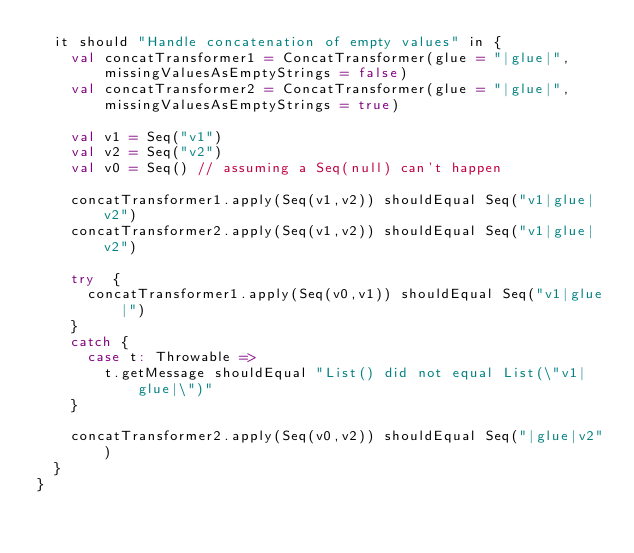Convert code to text. <code><loc_0><loc_0><loc_500><loc_500><_Scala_>  it should "Handle concatenation of empty values" in {
    val concatTransformer1 = ConcatTransformer(glue = "|glue|", missingValuesAsEmptyStrings = false)
    val concatTransformer2 = ConcatTransformer(glue = "|glue|", missingValuesAsEmptyStrings = true)

    val v1 = Seq("v1")
    val v2 = Seq("v2")
    val v0 = Seq() // assuming a Seq(null) can't happen

    concatTransformer1.apply(Seq(v1,v2)) shouldEqual Seq("v1|glue|v2")
    concatTransformer2.apply(Seq(v1,v2)) shouldEqual Seq("v1|glue|v2")

    try  {
      concatTransformer1.apply(Seq(v0,v1)) shouldEqual Seq("v1|glue|")
    }
    catch {
      case t: Throwable =>
        t.getMessage shouldEqual "List() did not equal List(\"v1|glue|\")"
    }

    concatTransformer2.apply(Seq(v0,v2)) shouldEqual Seq("|glue|v2")
  }
}
</code> 